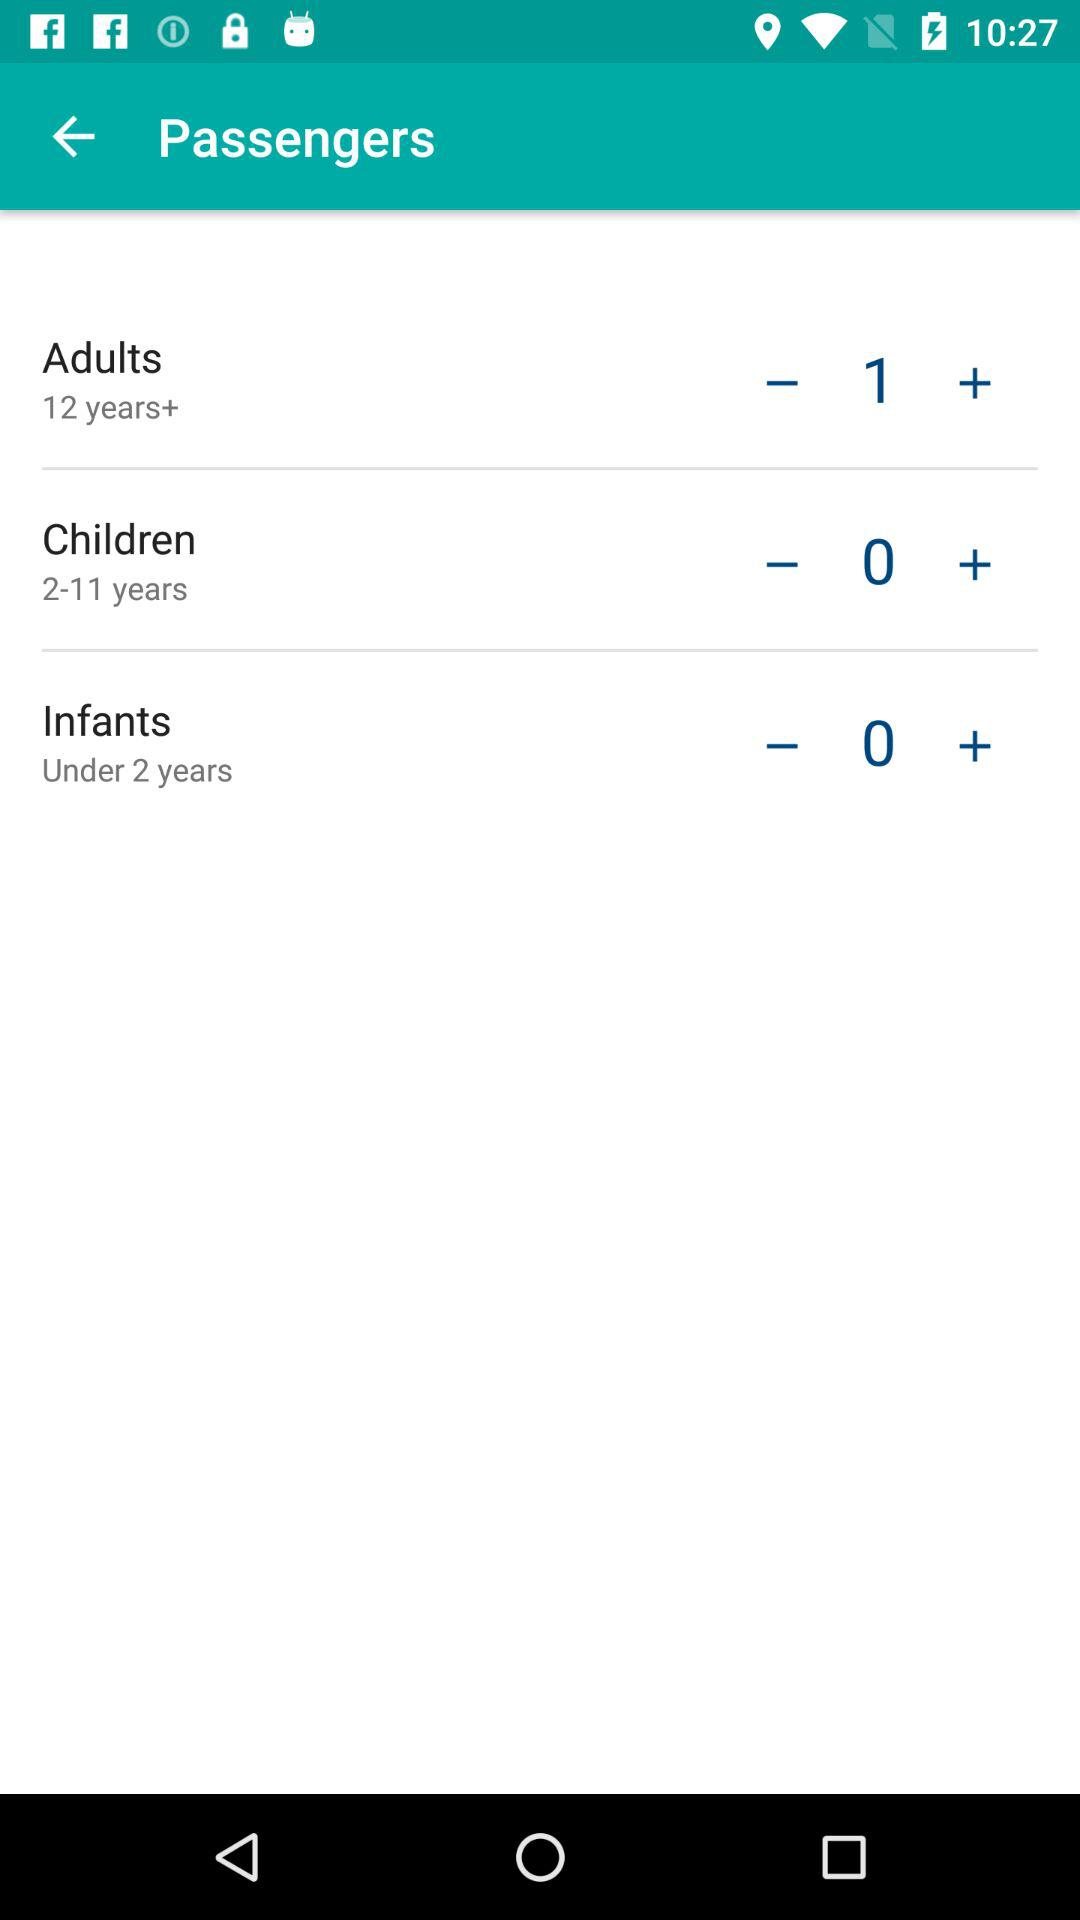How many passengers are adults? There is 1 passenger, who is an adult. 